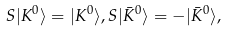<formula> <loc_0><loc_0><loc_500><loc_500>S | K ^ { 0 } \rangle = | K ^ { 0 } \rangle , S | \bar { K } ^ { 0 } \rangle = - | \bar { K } ^ { 0 } \rangle ,</formula> 